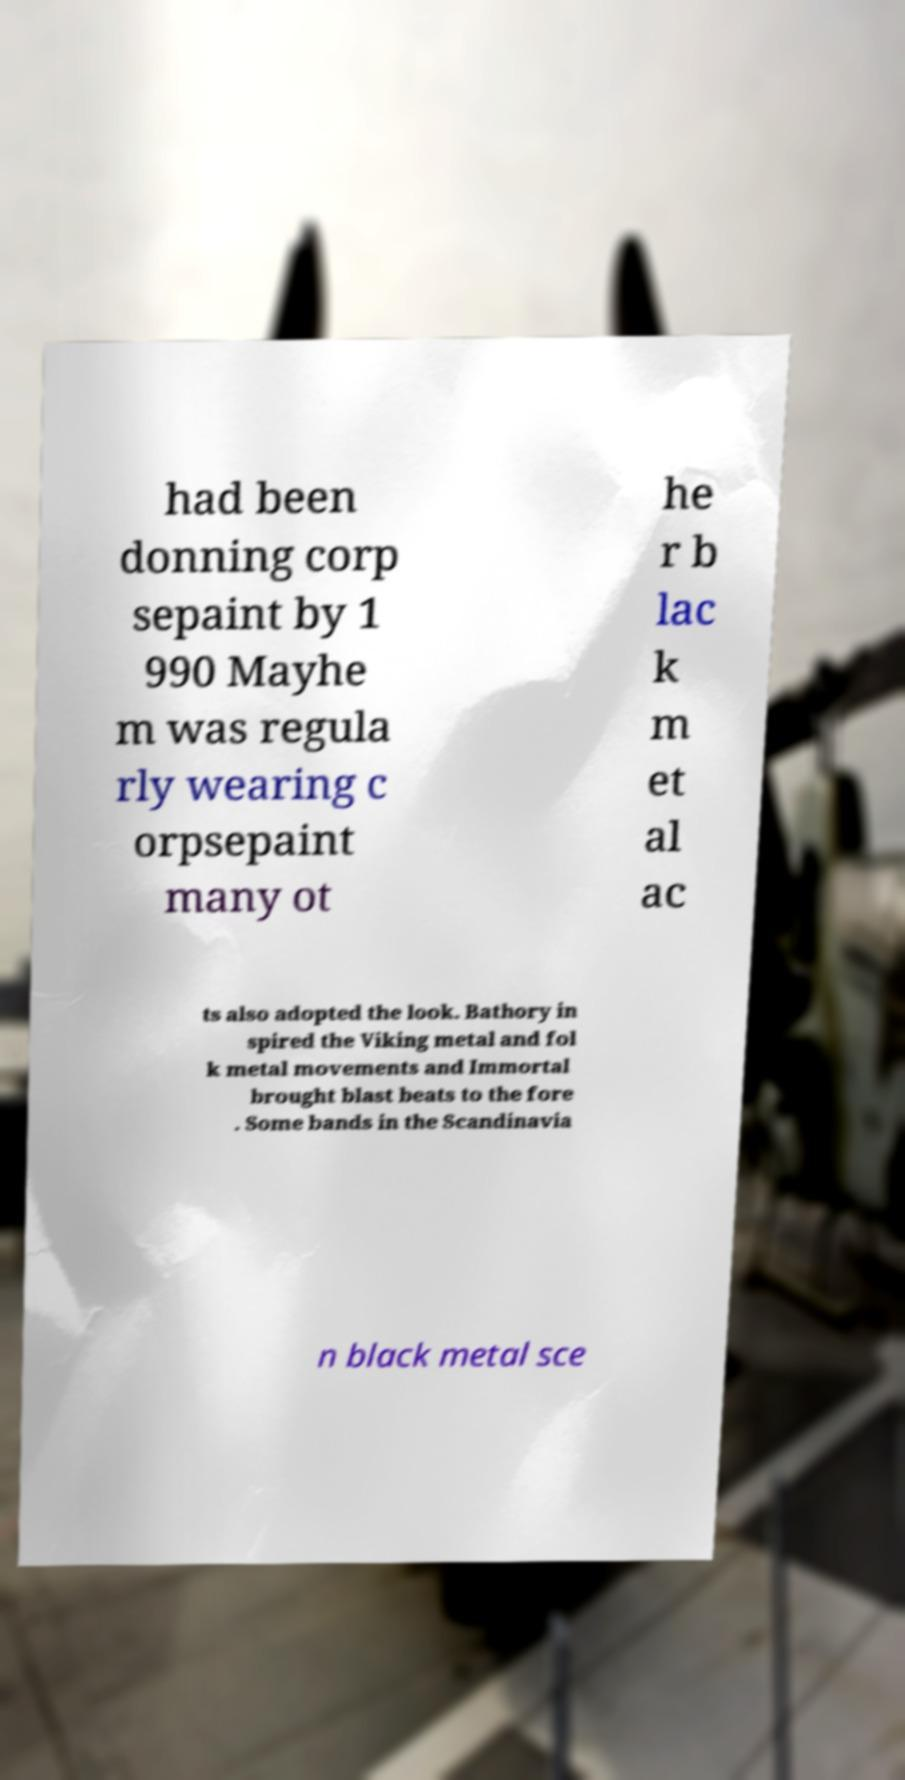For documentation purposes, I need the text within this image transcribed. Could you provide that? had been donning corp sepaint by 1 990 Mayhe m was regula rly wearing c orpsepaint many ot he r b lac k m et al ac ts also adopted the look. Bathory in spired the Viking metal and fol k metal movements and Immortal brought blast beats to the fore . Some bands in the Scandinavia n black metal sce 